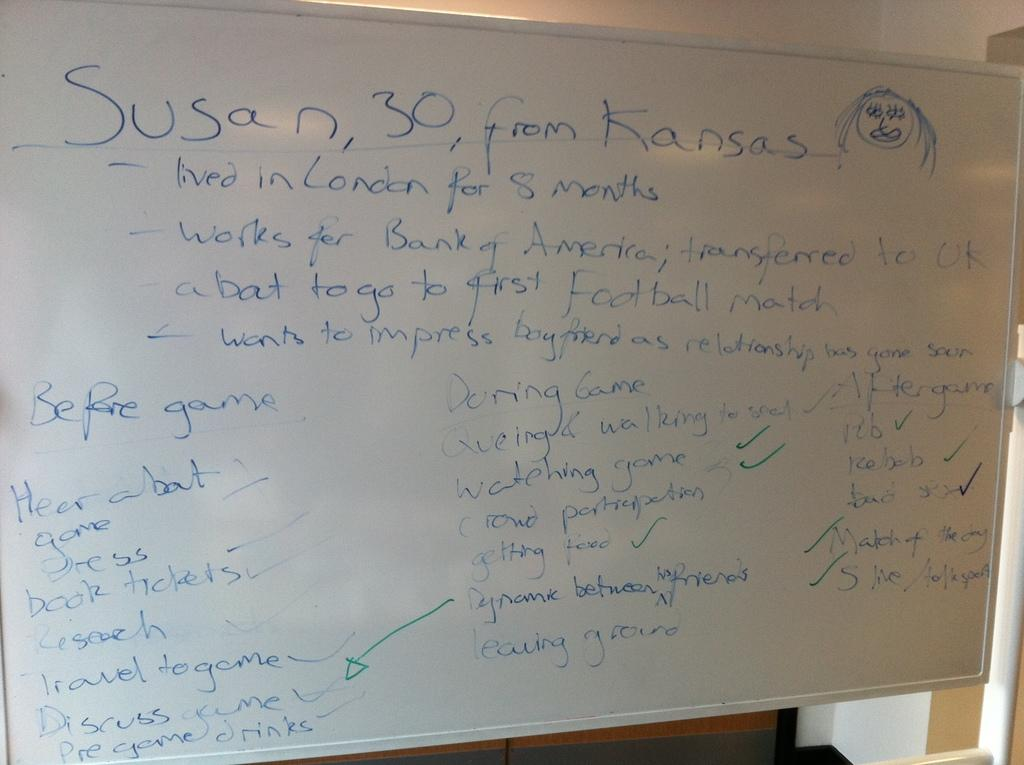<image>
Provide a brief description of the given image. A whiteboard with lots of writing in blue titled Susan 30 from Kansas. 